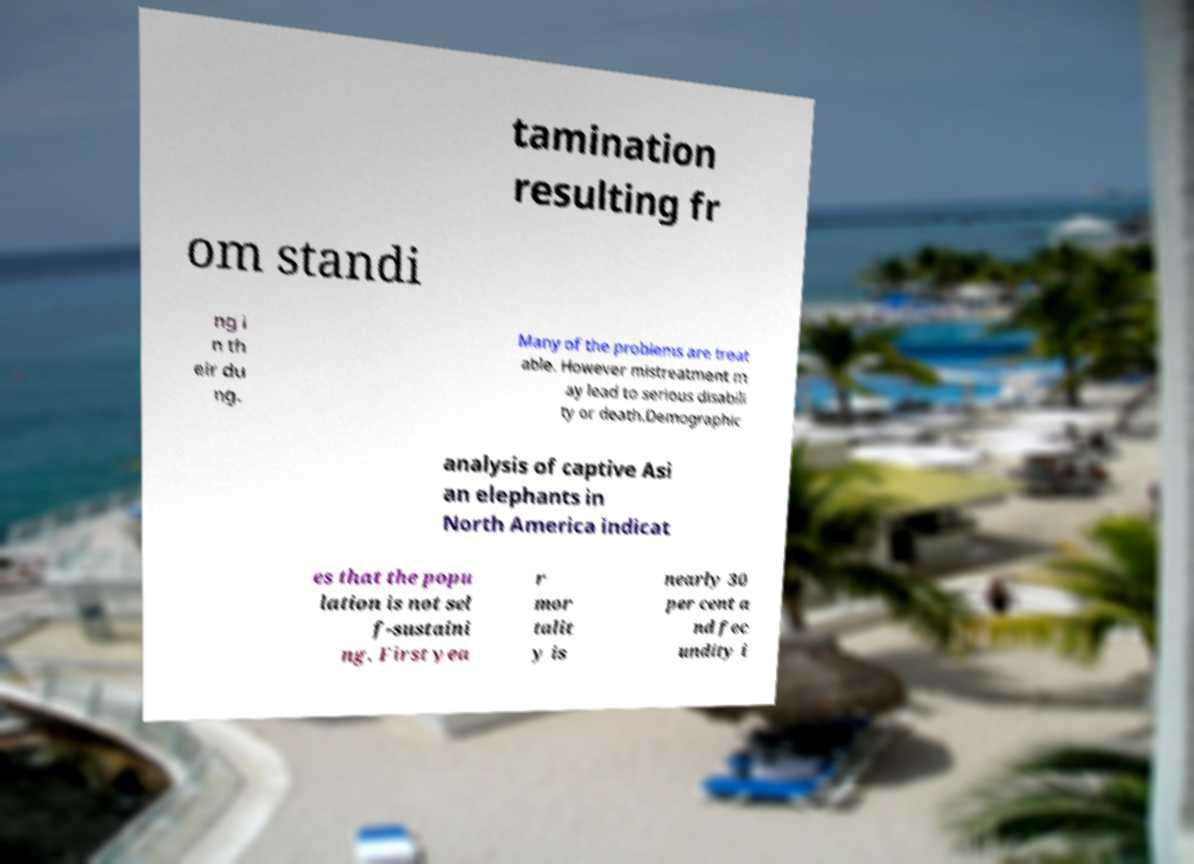Could you assist in decoding the text presented in this image and type it out clearly? tamination resulting fr om standi ng i n th eir du ng. Many of the problems are treat able. However mistreatment m ay lead to serious disabili ty or death.Demographic analysis of captive Asi an elephants in North America indicat es that the popu lation is not sel f-sustaini ng. First yea r mor talit y is nearly 30 per cent a nd fec undity i 